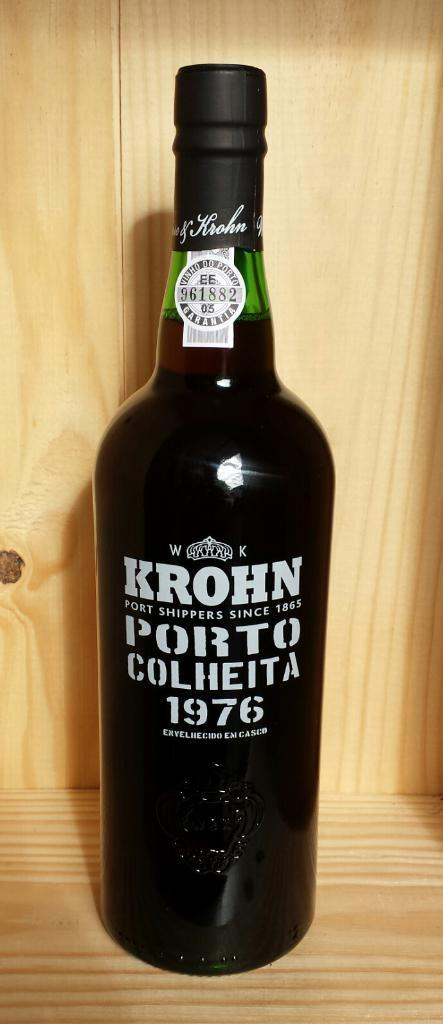<image>
Render a clear and concise summary of the photo. a dark green bottle of 1976 krohn porto colheita 